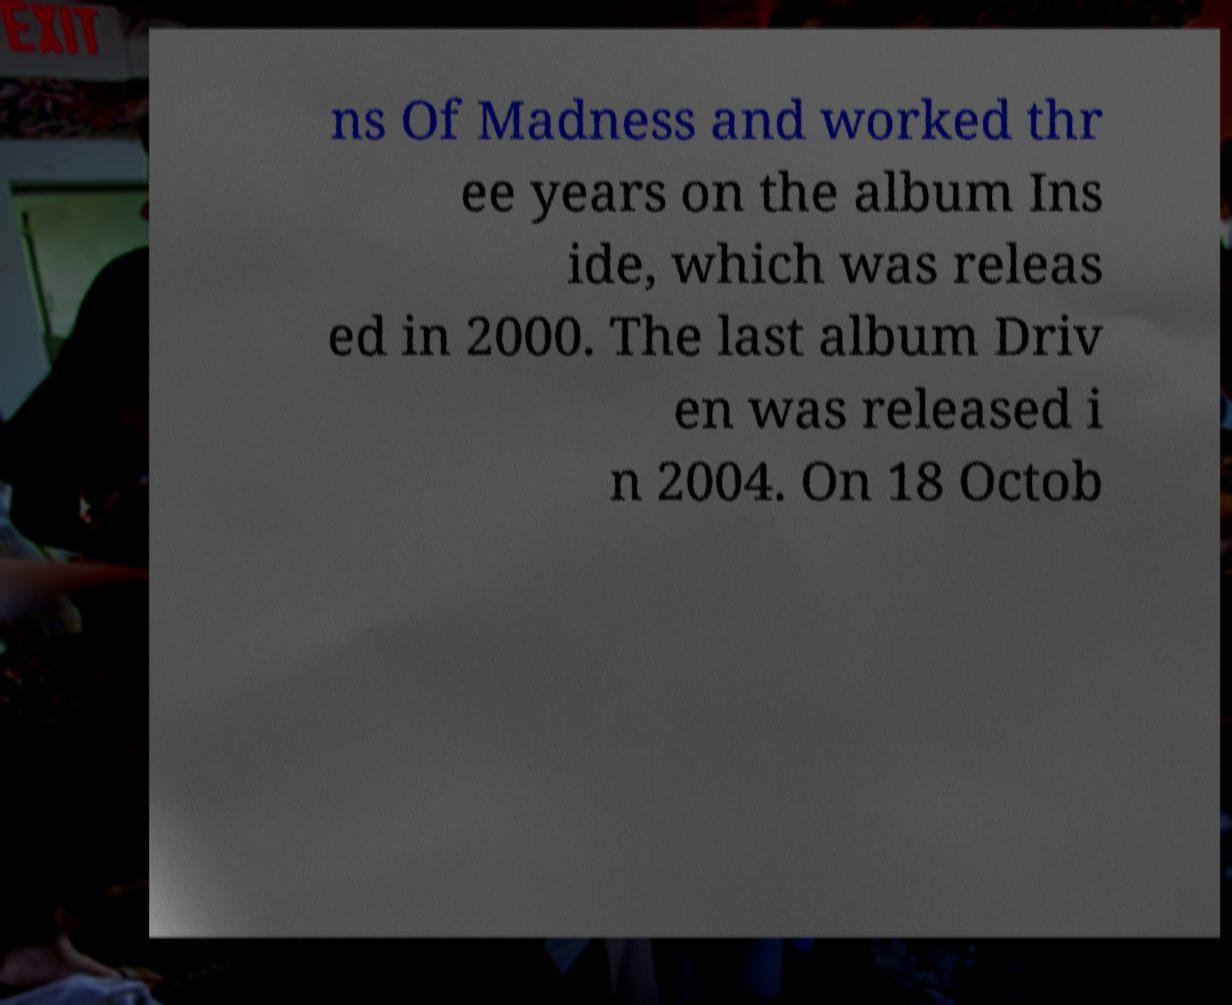Could you assist in decoding the text presented in this image and type it out clearly? ns Of Madness and worked thr ee years on the album Ins ide, which was releas ed in 2000. The last album Driv en was released i n 2004. On 18 Octob 